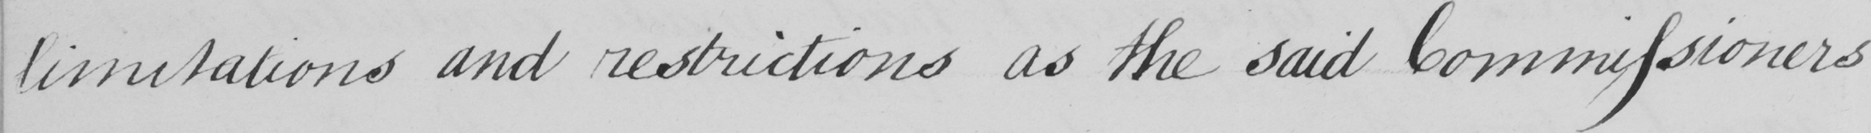What does this handwritten line say? limitations and restrictions as the said Commissioners 